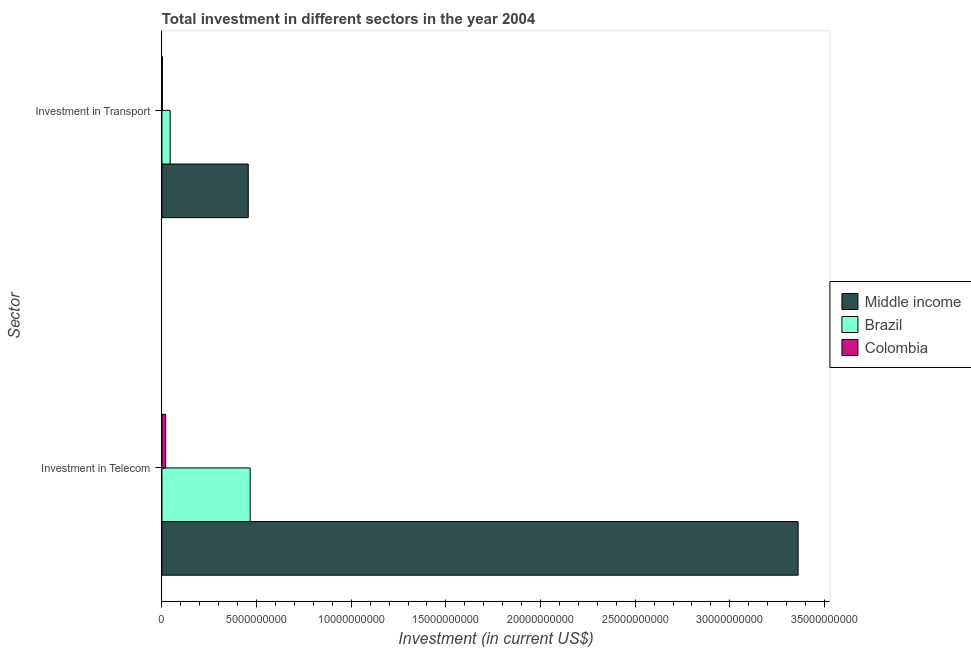How many groups of bars are there?
Keep it short and to the point. 2. Are the number of bars per tick equal to the number of legend labels?
Ensure brevity in your answer.  Yes. Are the number of bars on each tick of the Y-axis equal?
Your response must be concise. Yes. How many bars are there on the 2nd tick from the top?
Give a very brief answer. 3. How many bars are there on the 2nd tick from the bottom?
Keep it short and to the point. 3. What is the label of the 1st group of bars from the top?
Ensure brevity in your answer.  Investment in Transport. What is the investment in transport in Brazil?
Your answer should be very brief. 4.34e+08. Across all countries, what is the maximum investment in transport?
Your answer should be compact. 4.56e+09. Across all countries, what is the minimum investment in telecom?
Keep it short and to the point. 1.98e+08. In which country was the investment in telecom minimum?
Your answer should be very brief. Colombia. What is the total investment in telecom in the graph?
Provide a succinct answer. 3.85e+1. What is the difference between the investment in transport in Middle income and that in Colombia?
Keep it short and to the point. 4.53e+09. What is the difference between the investment in telecom in Colombia and the investment in transport in Brazil?
Give a very brief answer. -2.35e+08. What is the average investment in telecom per country?
Your response must be concise. 1.28e+1. What is the difference between the investment in transport and investment in telecom in Brazil?
Ensure brevity in your answer.  -4.23e+09. In how many countries, is the investment in telecom greater than 6000000000 US$?
Offer a terse response. 1. What is the ratio of the investment in transport in Brazil to that in Colombia?
Your answer should be very brief. 16.68. What does the 1st bar from the top in Investment in Telecom represents?
Your response must be concise. Colombia. Are all the bars in the graph horizontal?
Your answer should be compact. Yes. How many countries are there in the graph?
Make the answer very short. 3. Are the values on the major ticks of X-axis written in scientific E-notation?
Offer a terse response. No. Does the graph contain grids?
Offer a very short reply. No. What is the title of the graph?
Keep it short and to the point. Total investment in different sectors in the year 2004. What is the label or title of the X-axis?
Offer a terse response. Investment (in current US$). What is the label or title of the Y-axis?
Provide a short and direct response. Sector. What is the Investment (in current US$) of Middle income in Investment in Telecom?
Keep it short and to the point. 3.36e+1. What is the Investment (in current US$) in Brazil in Investment in Telecom?
Offer a terse response. 4.66e+09. What is the Investment (in current US$) of Colombia in Investment in Telecom?
Ensure brevity in your answer.  1.98e+08. What is the Investment (in current US$) in Middle income in Investment in Transport?
Offer a terse response. 4.56e+09. What is the Investment (in current US$) of Brazil in Investment in Transport?
Your response must be concise. 4.34e+08. What is the Investment (in current US$) in Colombia in Investment in Transport?
Your answer should be very brief. 2.60e+07. Across all Sector, what is the maximum Investment (in current US$) of Middle income?
Your response must be concise. 3.36e+1. Across all Sector, what is the maximum Investment (in current US$) in Brazil?
Provide a succinct answer. 4.66e+09. Across all Sector, what is the maximum Investment (in current US$) of Colombia?
Give a very brief answer. 1.98e+08. Across all Sector, what is the minimum Investment (in current US$) of Middle income?
Offer a very short reply. 4.56e+09. Across all Sector, what is the minimum Investment (in current US$) of Brazil?
Provide a succinct answer. 4.34e+08. Across all Sector, what is the minimum Investment (in current US$) of Colombia?
Offer a very short reply. 2.60e+07. What is the total Investment (in current US$) in Middle income in the graph?
Your answer should be very brief. 3.82e+1. What is the total Investment (in current US$) in Brazil in the graph?
Offer a very short reply. 5.09e+09. What is the total Investment (in current US$) in Colombia in the graph?
Your response must be concise. 2.24e+08. What is the difference between the Investment (in current US$) in Middle income in Investment in Telecom and that in Investment in Transport?
Offer a terse response. 2.90e+1. What is the difference between the Investment (in current US$) of Brazil in Investment in Telecom and that in Investment in Transport?
Your answer should be compact. 4.23e+09. What is the difference between the Investment (in current US$) in Colombia in Investment in Telecom and that in Investment in Transport?
Your answer should be compact. 1.72e+08. What is the difference between the Investment (in current US$) of Middle income in Investment in Telecom and the Investment (in current US$) of Brazil in Investment in Transport?
Your response must be concise. 3.32e+1. What is the difference between the Investment (in current US$) of Middle income in Investment in Telecom and the Investment (in current US$) of Colombia in Investment in Transport?
Your answer should be compact. 3.36e+1. What is the difference between the Investment (in current US$) of Brazil in Investment in Telecom and the Investment (in current US$) of Colombia in Investment in Transport?
Your answer should be very brief. 4.63e+09. What is the average Investment (in current US$) of Middle income per Sector?
Your response must be concise. 1.91e+1. What is the average Investment (in current US$) of Brazil per Sector?
Keep it short and to the point. 2.55e+09. What is the average Investment (in current US$) in Colombia per Sector?
Provide a short and direct response. 1.12e+08. What is the difference between the Investment (in current US$) of Middle income and Investment (in current US$) of Brazil in Investment in Telecom?
Ensure brevity in your answer.  2.89e+1. What is the difference between the Investment (in current US$) in Middle income and Investment (in current US$) in Colombia in Investment in Telecom?
Your response must be concise. 3.34e+1. What is the difference between the Investment (in current US$) in Brazil and Investment (in current US$) in Colombia in Investment in Telecom?
Your answer should be compact. 4.46e+09. What is the difference between the Investment (in current US$) in Middle income and Investment (in current US$) in Brazil in Investment in Transport?
Your answer should be compact. 4.12e+09. What is the difference between the Investment (in current US$) in Middle income and Investment (in current US$) in Colombia in Investment in Transport?
Your answer should be compact. 4.53e+09. What is the difference between the Investment (in current US$) in Brazil and Investment (in current US$) in Colombia in Investment in Transport?
Keep it short and to the point. 4.08e+08. What is the ratio of the Investment (in current US$) of Middle income in Investment in Telecom to that in Investment in Transport?
Ensure brevity in your answer.  7.37. What is the ratio of the Investment (in current US$) in Brazil in Investment in Telecom to that in Investment in Transport?
Offer a very short reply. 10.75. What is the ratio of the Investment (in current US$) in Colombia in Investment in Telecom to that in Investment in Transport?
Your response must be concise. 7.63. What is the difference between the highest and the second highest Investment (in current US$) in Middle income?
Keep it short and to the point. 2.90e+1. What is the difference between the highest and the second highest Investment (in current US$) in Brazil?
Your answer should be compact. 4.23e+09. What is the difference between the highest and the second highest Investment (in current US$) of Colombia?
Give a very brief answer. 1.72e+08. What is the difference between the highest and the lowest Investment (in current US$) in Middle income?
Your answer should be compact. 2.90e+1. What is the difference between the highest and the lowest Investment (in current US$) in Brazil?
Your response must be concise. 4.23e+09. What is the difference between the highest and the lowest Investment (in current US$) in Colombia?
Offer a terse response. 1.72e+08. 